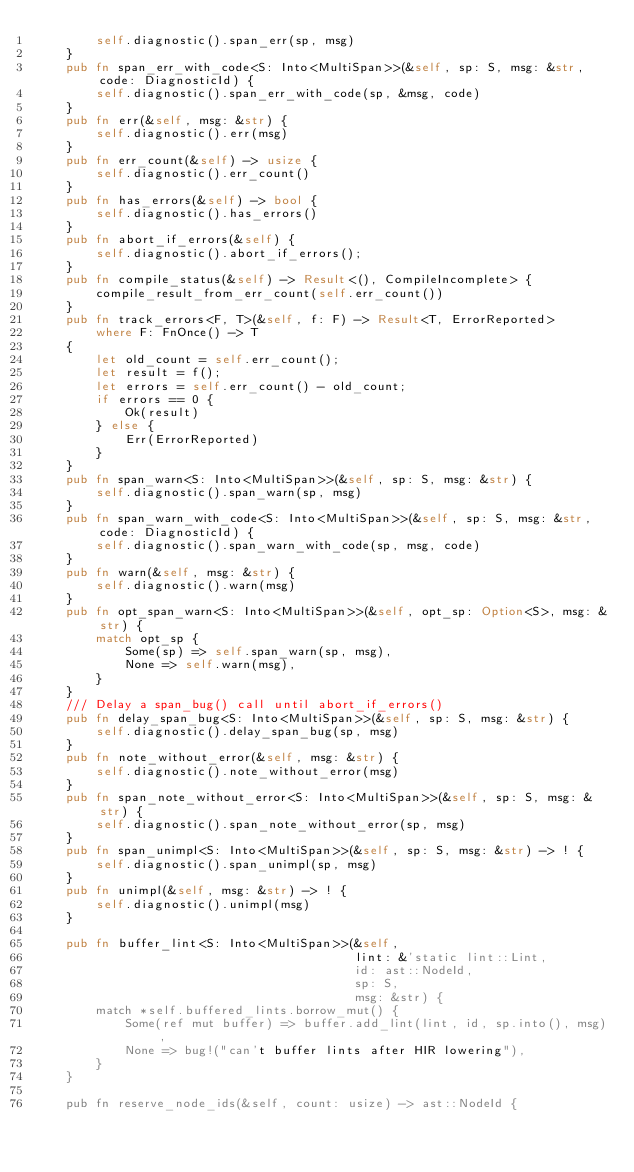<code> <loc_0><loc_0><loc_500><loc_500><_Rust_>        self.diagnostic().span_err(sp, msg)
    }
    pub fn span_err_with_code<S: Into<MultiSpan>>(&self, sp: S, msg: &str, code: DiagnosticId) {
        self.diagnostic().span_err_with_code(sp, &msg, code)
    }
    pub fn err(&self, msg: &str) {
        self.diagnostic().err(msg)
    }
    pub fn err_count(&self) -> usize {
        self.diagnostic().err_count()
    }
    pub fn has_errors(&self) -> bool {
        self.diagnostic().has_errors()
    }
    pub fn abort_if_errors(&self) {
        self.diagnostic().abort_if_errors();
    }
    pub fn compile_status(&self) -> Result<(), CompileIncomplete> {
        compile_result_from_err_count(self.err_count())
    }
    pub fn track_errors<F, T>(&self, f: F) -> Result<T, ErrorReported>
        where F: FnOnce() -> T
    {
        let old_count = self.err_count();
        let result = f();
        let errors = self.err_count() - old_count;
        if errors == 0 {
            Ok(result)
        } else {
            Err(ErrorReported)
        }
    }
    pub fn span_warn<S: Into<MultiSpan>>(&self, sp: S, msg: &str) {
        self.diagnostic().span_warn(sp, msg)
    }
    pub fn span_warn_with_code<S: Into<MultiSpan>>(&self, sp: S, msg: &str, code: DiagnosticId) {
        self.diagnostic().span_warn_with_code(sp, msg, code)
    }
    pub fn warn(&self, msg: &str) {
        self.diagnostic().warn(msg)
    }
    pub fn opt_span_warn<S: Into<MultiSpan>>(&self, opt_sp: Option<S>, msg: &str) {
        match opt_sp {
            Some(sp) => self.span_warn(sp, msg),
            None => self.warn(msg),
        }
    }
    /// Delay a span_bug() call until abort_if_errors()
    pub fn delay_span_bug<S: Into<MultiSpan>>(&self, sp: S, msg: &str) {
        self.diagnostic().delay_span_bug(sp, msg)
    }
    pub fn note_without_error(&self, msg: &str) {
        self.diagnostic().note_without_error(msg)
    }
    pub fn span_note_without_error<S: Into<MultiSpan>>(&self, sp: S, msg: &str) {
        self.diagnostic().span_note_without_error(sp, msg)
    }
    pub fn span_unimpl<S: Into<MultiSpan>>(&self, sp: S, msg: &str) -> ! {
        self.diagnostic().span_unimpl(sp, msg)
    }
    pub fn unimpl(&self, msg: &str) -> ! {
        self.diagnostic().unimpl(msg)
    }

    pub fn buffer_lint<S: Into<MultiSpan>>(&self,
                                           lint: &'static lint::Lint,
                                           id: ast::NodeId,
                                           sp: S,
                                           msg: &str) {
        match *self.buffered_lints.borrow_mut() {
            Some(ref mut buffer) => buffer.add_lint(lint, id, sp.into(), msg),
            None => bug!("can't buffer lints after HIR lowering"),
        }
    }

    pub fn reserve_node_ids(&self, count: usize) -> ast::NodeId {</code> 